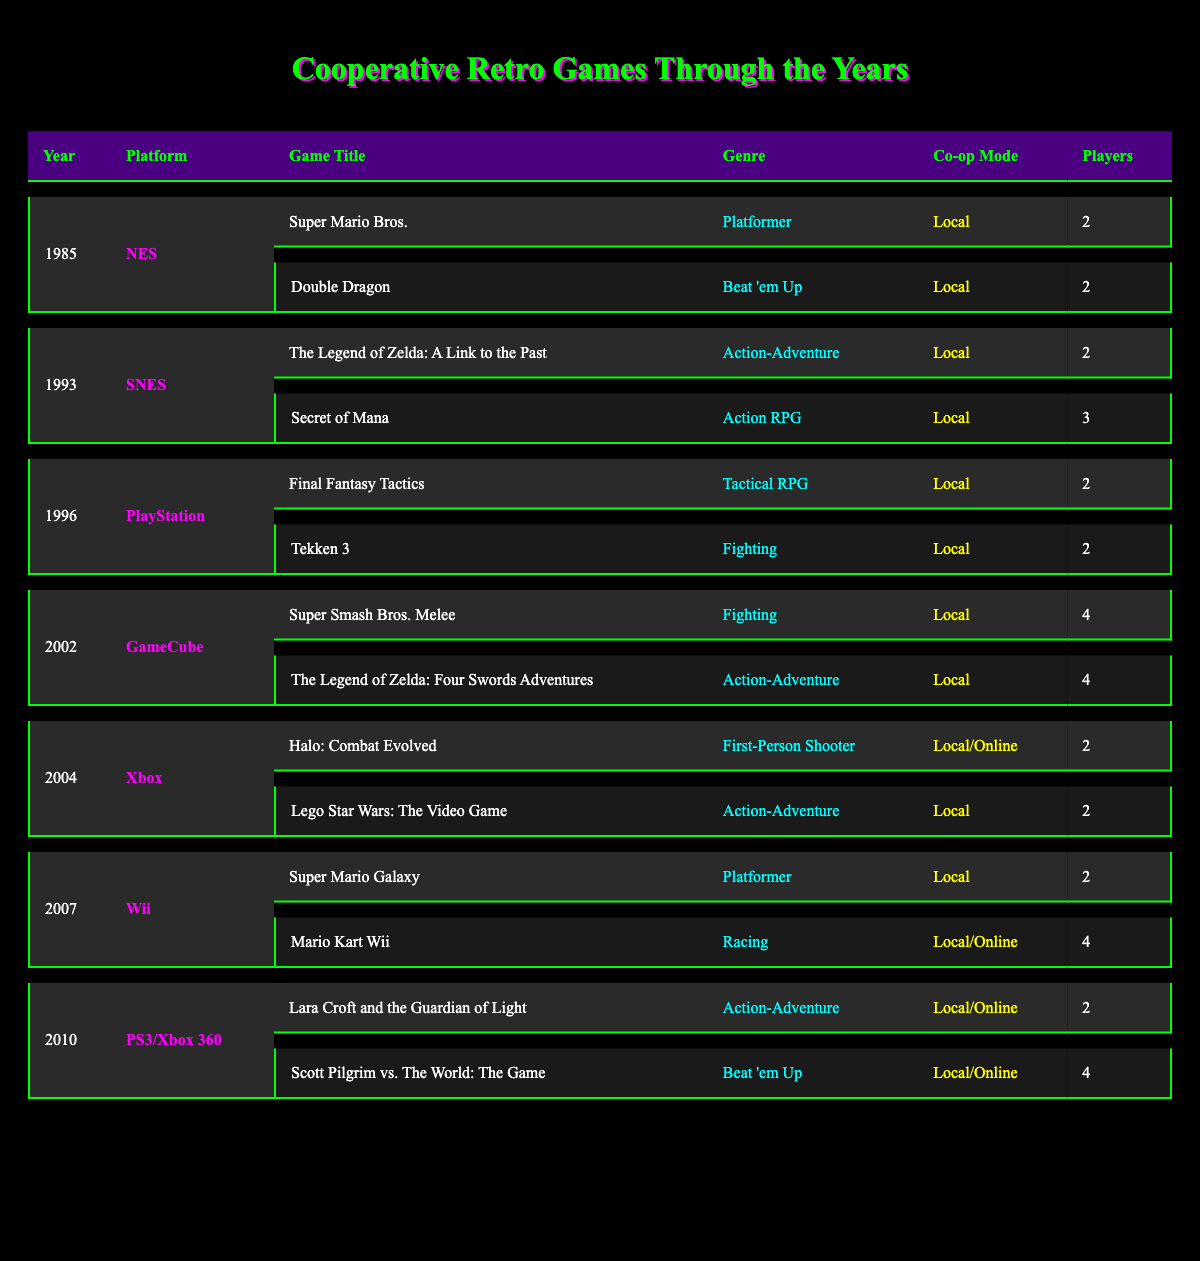What is the genre of "Secret of Mana"? The table lists "Secret of Mana" under the year 1993 and indicates that its genre is "Action RPG."
Answer: Action RPG How many players can participate in "Super Smash Bros. Melee"? The table shows that "Super Smash Bros. Melee" allows 4 players to participate.
Answer: 4 players Which game was released in 2007 and belongs to the Racing genre? According to the table, the game released in 2007 that is categorized under the Racing genre is "Mario Kart Wii."
Answer: Mario Kart Wii Is "Halo: Combat Evolved" available in local co-op mode? The table indicates that "Halo: Combat Evolved" has a co-op mode that includes "Local," affirming its availability in local play.
Answer: Yes What is the total number of players supported by the "Scott Pilgrim vs. The World: The Game"? The table shows that "Scott Pilgrim vs. The World: The Game" supports 4 players in its multiplayer mode.
Answer: 4 players Which platform had the highest number of players for a game released in 2002? By examining the table, “Super Smash Bros. Melee” and “The Legend of Zelda: Four Swords Adventures” both support 4 players on the GameCube, which is the highest count for that year.
Answer: GameCube (4 players) How many Action-Adventure games can we find in the table? The table lists 3 Action-Adventure games: "The Legend of Zelda: A Link to the Past," "The Legend of Zelda: Four Swords Adventures," and "Lara Croft and the Guardian of Light." Therefore, the total number is 3.
Answer: 3 games What genres are represented in the year 1996? The table indicates that 1996 has two genres represented: "Tactical RPG" (Final Fantasy Tactics) and "Fighting" (Tekken 3).
Answer: 2 genres (Tactical RPG, Fighting) Considering all the games, which genre has the maximum player capacity? The table shows "Fighting" with "Super Smash Bros. Melee," which allows 4 players, the maximum amongst all listed genres.
Answer: Fighting (4 players) In the years 2004 and 2007, which platform had more games listed? From the table, the year 2004 has 2 games and 2007 also has 2 games, resulting in an equal count.
Answer: Both years have the same number of games (2) 